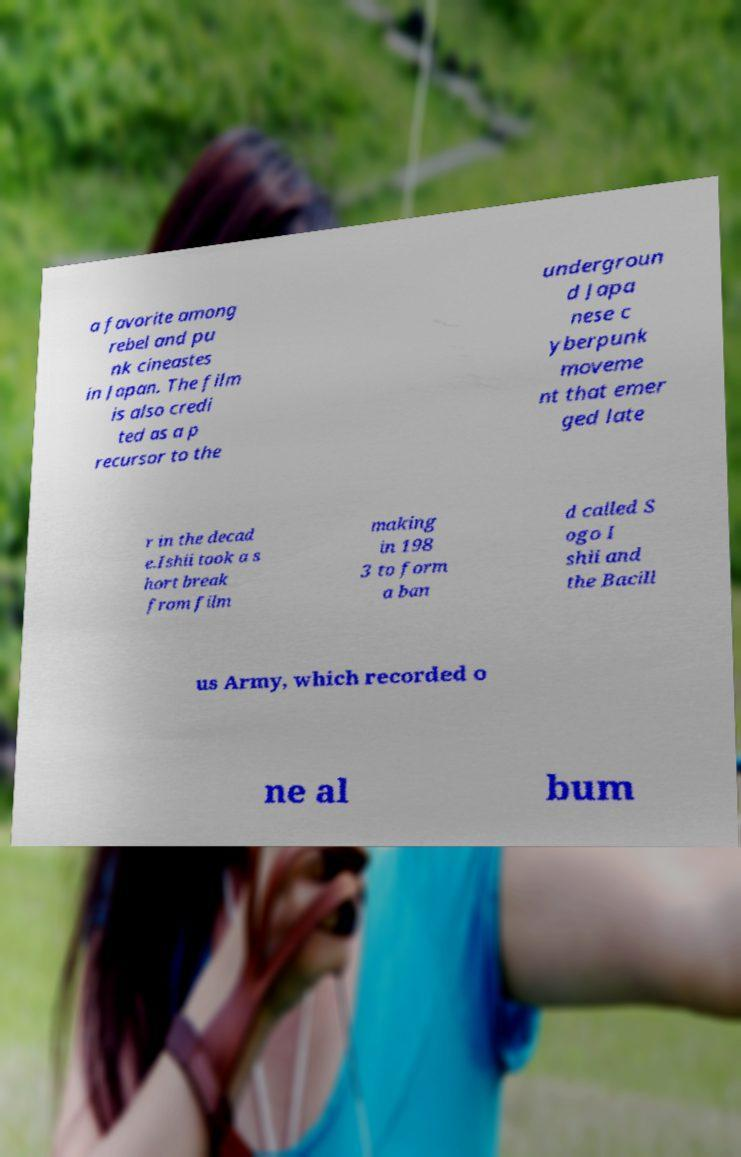Can you read and provide the text displayed in the image?This photo seems to have some interesting text. Can you extract and type it out for me? a favorite among rebel and pu nk cineastes in Japan. The film is also credi ted as a p recursor to the undergroun d Japa nese c yberpunk moveme nt that emer ged late r in the decad e.Ishii took a s hort break from film making in 198 3 to form a ban d called S ogo I shii and the Bacill us Army, which recorded o ne al bum 